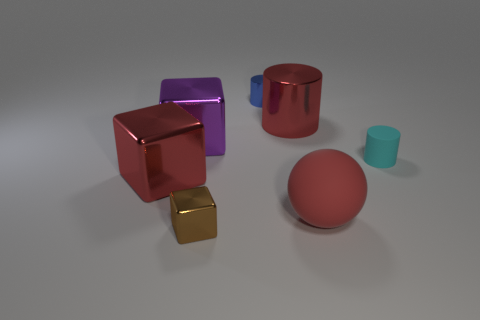Add 3 small metal cylinders. How many objects exist? 10 Subtract all cubes. How many objects are left? 4 Subtract 0 yellow cylinders. How many objects are left? 7 Subtract all red matte things. Subtract all small blue metal things. How many objects are left? 5 Add 5 purple objects. How many purple objects are left? 6 Add 5 small brown shiny things. How many small brown shiny things exist? 6 